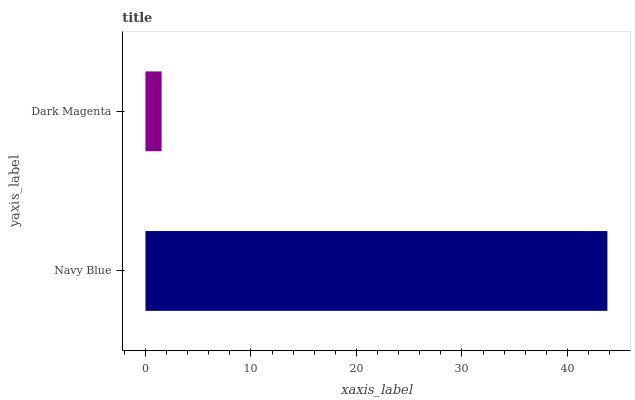Is Dark Magenta the minimum?
Answer yes or no. Yes. Is Navy Blue the maximum?
Answer yes or no. Yes. Is Dark Magenta the maximum?
Answer yes or no. No. Is Navy Blue greater than Dark Magenta?
Answer yes or no. Yes. Is Dark Magenta less than Navy Blue?
Answer yes or no. Yes. Is Dark Magenta greater than Navy Blue?
Answer yes or no. No. Is Navy Blue less than Dark Magenta?
Answer yes or no. No. Is Navy Blue the high median?
Answer yes or no. Yes. Is Dark Magenta the low median?
Answer yes or no. Yes. Is Dark Magenta the high median?
Answer yes or no. No. Is Navy Blue the low median?
Answer yes or no. No. 